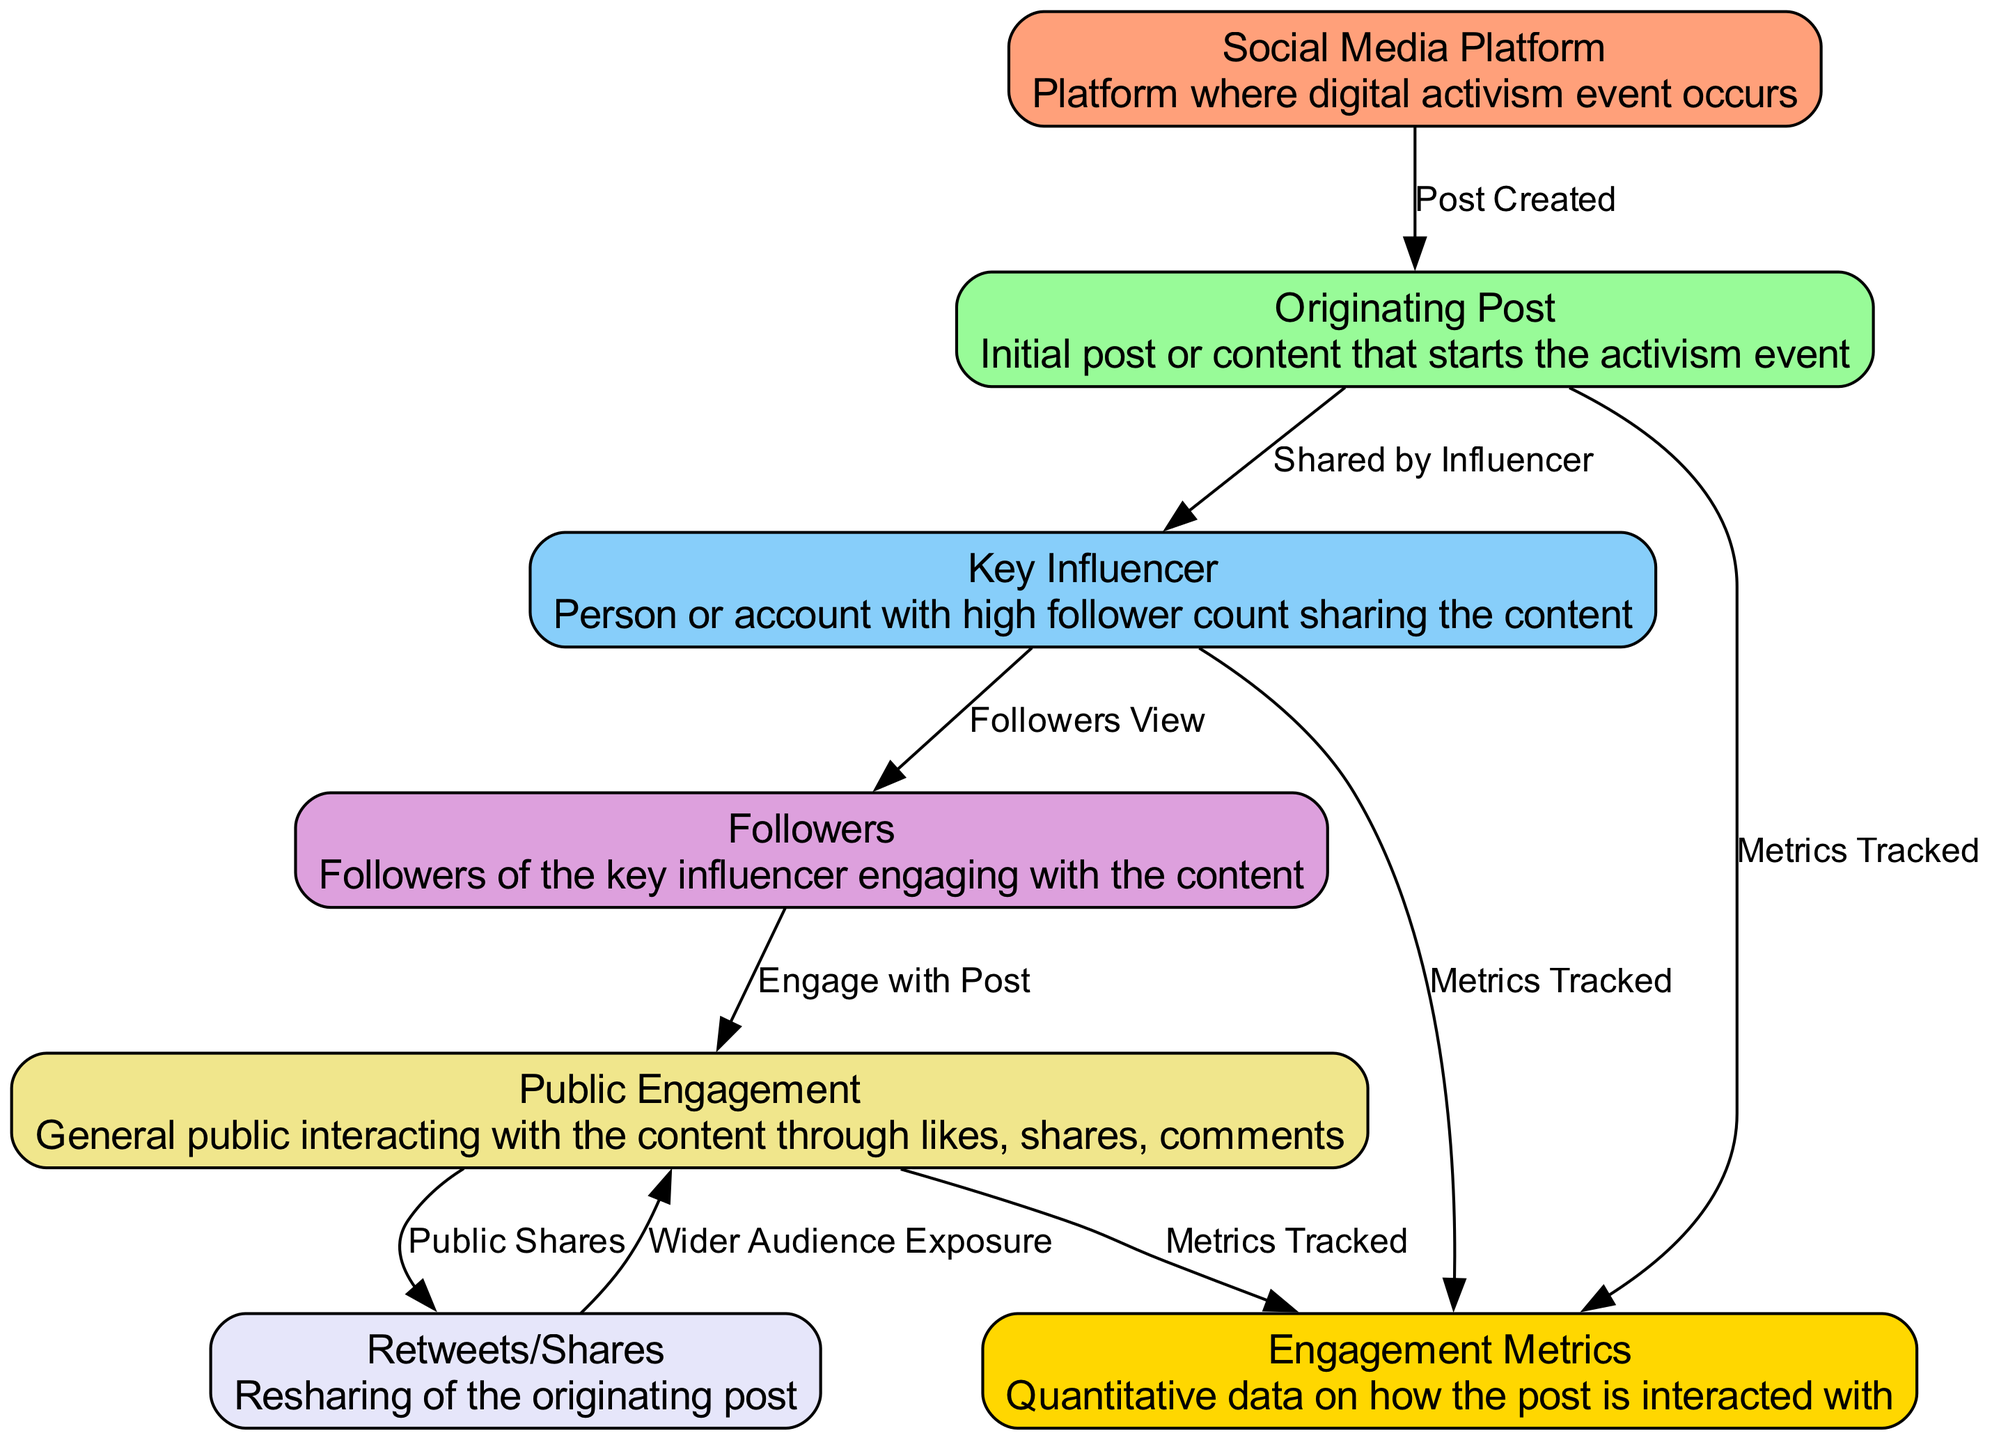What is the first node in the flow of data? The first node represents the starting point of the flow, which is the "Social Media Platform". This node is where the digital activism event takes place.
Answer: Social Media Platform How many nodes are there in total? By counting each unique node listed within the diagram data, there are a total of six distinct nodes representing different elements in the data flow.
Answer: Six What type of engagement is shown on the edge between followers and public engagement? This edge indicates that followers engage with the post. It establishes the interaction relationship between followers and the subsequent engagement with the posting.
Answer: Engage with Post Which nodes track engagement metrics? The "Originating Post," "Key Influencer," and "Public Engagement" nodes are all involved in tracking engagement metrics, indicating multiple points where metrics are gathered throughout the data flow.
Answer: Originating Post, Key Influencer, Public Engagement What does the edge from public engagement to retweets/shares signify? This edge signifies that public engagement leads to the action of sharing the content. It connects the engagement by the public to the act of resharing, widening exposure to the content.
Answer: Public Shares What is the relationship defined by the edge from the key influencer to followers? This relationship indicates that followers view the content shared by the key influencer. This reflects the dissemination of information from influencer to their followers, which is crucial in the flow of data.
Answer: Followers View What happens as a result of retweets/shares according to the diagram? The retweets/shares lead to wider audience exposure, indicating that the act of sharing propels the original content to a broader audience, amplifying its reach.
Answer: Wider Audience Exposure Which node does the originating post connect to for tracking metrics? The originating post connects directly to the engagement metrics node, highlighting that this particular post's performance is measured in terms of engagement.
Answer: Engagement Metrics What role do key influencers play in the data flow? Key influencers share the originating post, acting as significant nodes in the flow that help in amplifying the message to a larger audience, thus affecting the overall engagement metrics.
Answer: Shared by Influencer 